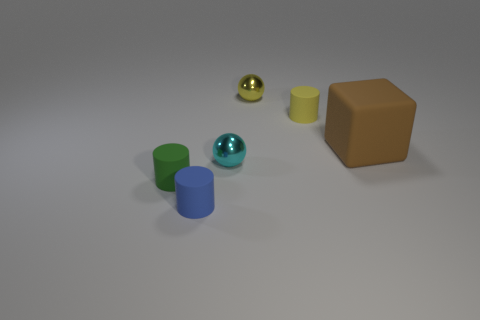Can you describe the textures that are visible on the objects in the image? Certainly! The objects display a variety of textures. The green cylinder seems to have a satiny finish, reflecting light evenly with a bit of shine. The sphere to the left has a highly reflective, smooth surface, likely indicating a polished metallic texture. The yellow cylinder and the blue matte cylinder both appear to have matte finishes, meaning they reflect light uniformly and have a flat texture. Lastly, the brown cube appears to be solid with a slightly rough texture, absorbing more light and providing a sense of density. 